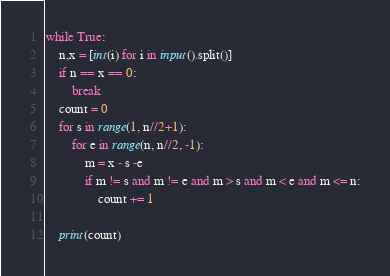<code> <loc_0><loc_0><loc_500><loc_500><_Python_>while True:
    n,x = [int(i) for i in input().split()]
    if n == x == 0:
        break
    count = 0
    for s in range(1, n//2+1):
        for e in range(n, n//2, -1):
            m = x - s -e
            if m != s and m != e and m > s and m < e and m <= n:
                count += 1

    print(count)</code> 